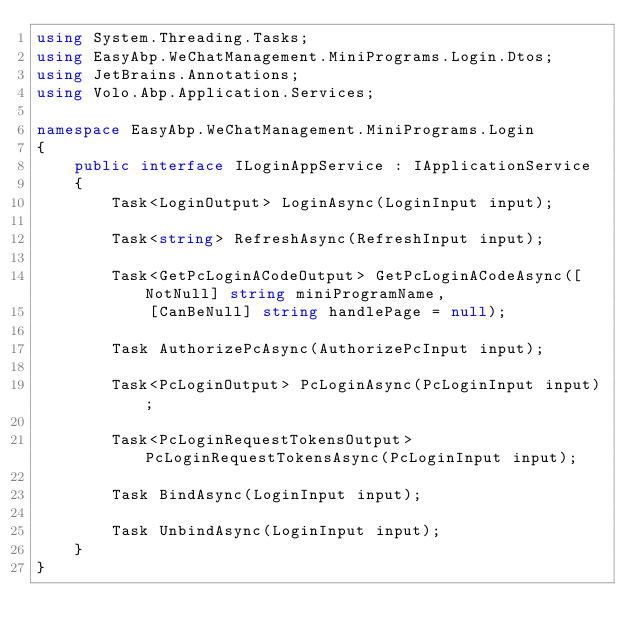Convert code to text. <code><loc_0><loc_0><loc_500><loc_500><_C#_>using System.Threading.Tasks;
using EasyAbp.WeChatManagement.MiniPrograms.Login.Dtos;
using JetBrains.Annotations;
using Volo.Abp.Application.Services;

namespace EasyAbp.WeChatManagement.MiniPrograms.Login
{
    public interface ILoginAppService : IApplicationService
    {
        Task<LoginOutput> LoginAsync(LoginInput input);
        
        Task<string> RefreshAsync(RefreshInput input);

        Task<GetPcLoginACodeOutput> GetPcLoginACodeAsync([NotNull] string miniProgramName,
            [CanBeNull] string handlePage = null);
        
        Task AuthorizePcAsync(AuthorizePcInput input);
        
        Task<PcLoginOutput> PcLoginAsync(PcLoginInput input);
        
        Task<PcLoginRequestTokensOutput> PcLoginRequestTokensAsync(PcLoginInput input);

        Task BindAsync(LoginInput input);

        Task UnbindAsync(LoginInput input);
    }
}</code> 